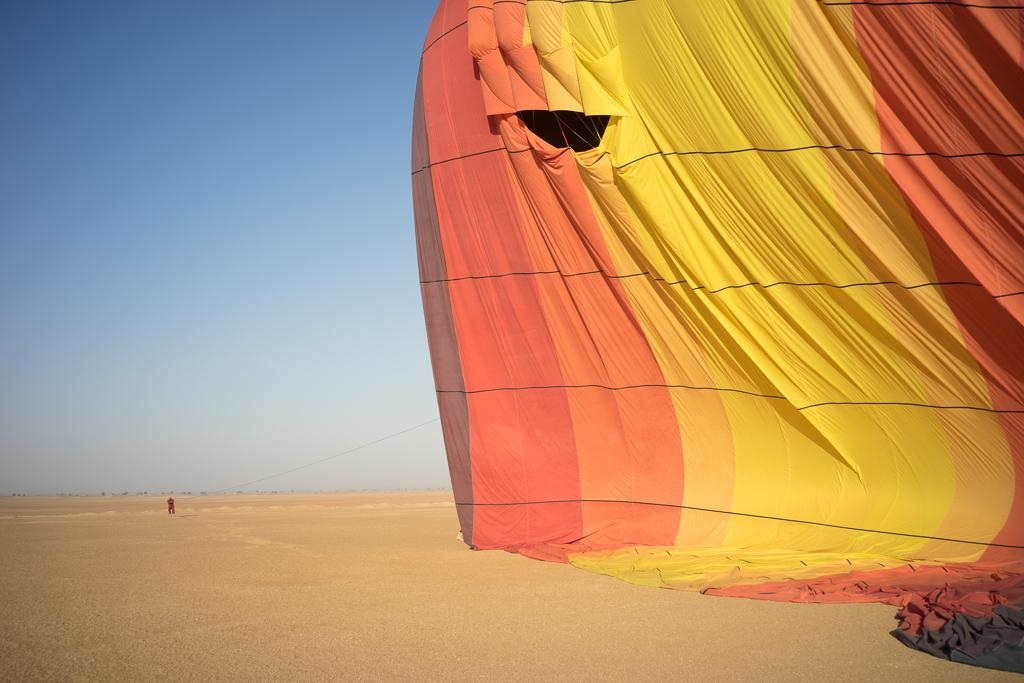What is located on the right side of the image? There is an air balloon on the right side of the image. Can you describe the background of the image? There is a person in the background of the image. What type of manager is overseeing the loss of the structure in the image? There is no manager, loss, or structure present in the image. 